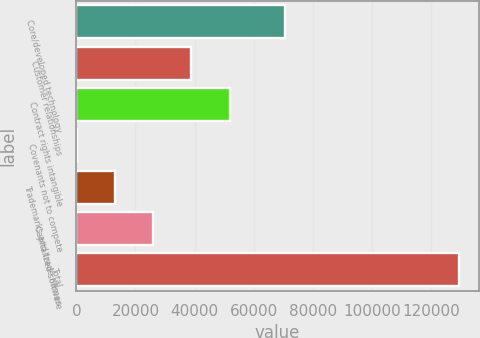Convert chart. <chart><loc_0><loc_0><loc_500><loc_500><bar_chart><fcel>Core/developed technology<fcel>Customer relationships<fcel>Contract rights intangible<fcel>Covenants not to compete<fcel>Trademarks and trade names<fcel>Capitalized software<fcel>Total<nl><fcel>70675<fcel>38945<fcel>51910<fcel>50<fcel>13015<fcel>25980<fcel>129700<nl></chart> 